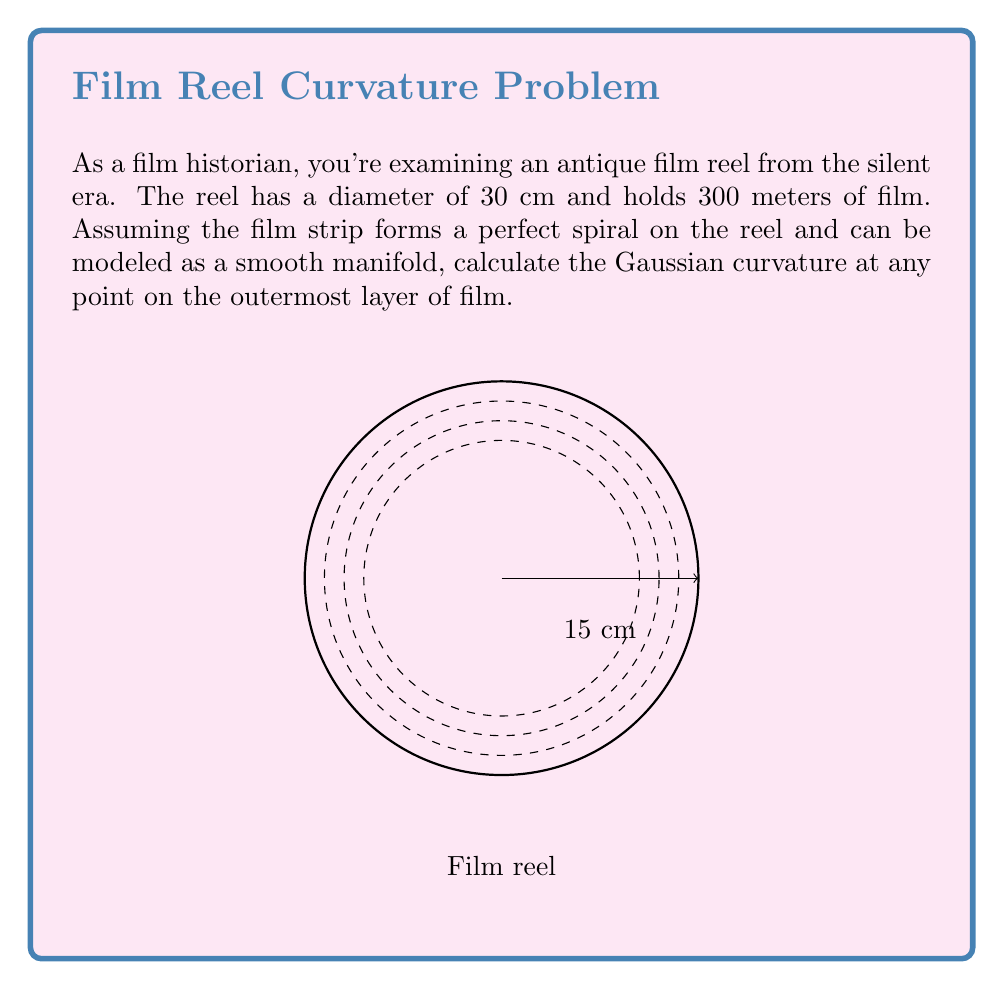Show me your answer to this math problem. To solve this problem, we'll follow these steps:

1) First, we need to understand that the film reel can be modeled as a spiral curve on a plane. The Gaussian curvature of a curve on a plane is always zero, but we can calculate the curvature of the spiral itself.

2) The equation of a spiral in polar coordinates is:
   $$r = a + b\theta$$
   where $a$ is the starting radius and $b$ is the rate of increase of the radius.

3) We can find $b$ by considering that 300 meters of film are wound around the reel:
   $$300 = \int_0^{2\pi n} \sqrt{r^2 + (\frac{dr}{d\theta})^2} d\theta$$
   where $n$ is the number of rotations.

4) This integral is complex, but we can approximate it with the arc length of circles:
   $$300 \approx 2\pi n \cdot \frac{15 + 0}{2} = 15\pi n$$
   
5) Solving for $n$:
   $$n \approx \frac{300}{15\pi} \approx 6.37$$

6) Now we can find $b$:
   $$b = \frac{15}{2\pi n} \approx 0.374$$

7) The curvature of a spiral in polar coordinates is given by:
   $$\kappa = \frac{|r^2 + 2(\frac{dr}{d\theta})^2 - r\frac{d^2r}{d\theta^2}|}{(r^2 + (\frac{dr}{d\theta})^2)^{3/2}}$$

8) For our spiral:
   $$\frac{dr}{d\theta} = b, \frac{d^2r}{d\theta^2} = 0$$

9) Substituting these and $r = 15$ (for the outermost layer) into the curvature formula:
   $$\kappa = \frac{|15^2 + 2(0.374)^2|}{(15^2 + 0.374^2)^{3/2}} \approx 0.0667$$
Answer: $\kappa \approx 0.0667 \text{ cm}^{-1}$ 